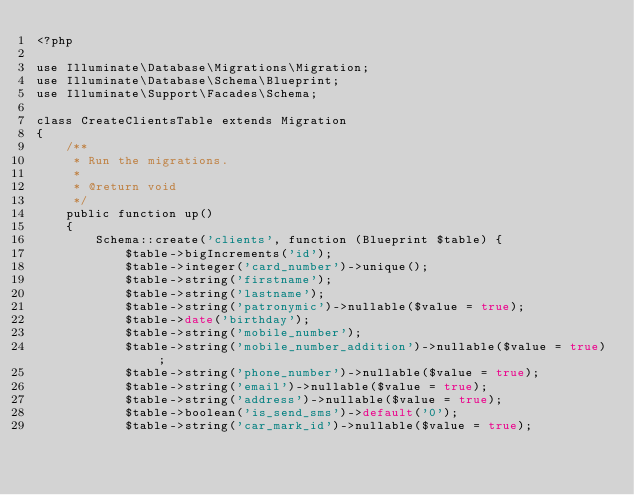<code> <loc_0><loc_0><loc_500><loc_500><_PHP_><?php

use Illuminate\Database\Migrations\Migration;
use Illuminate\Database\Schema\Blueprint;
use Illuminate\Support\Facades\Schema;

class CreateClientsTable extends Migration
{
    /**
     * Run the migrations.
     *
     * @return void
     */
    public function up()
    {
        Schema::create('clients', function (Blueprint $table) {
            $table->bigIncrements('id');
            $table->integer('card_number')->unique();
            $table->string('firstname');
            $table->string('lastname');
            $table->string('patronymic')->nullable($value = true);
            $table->date('birthday');
            $table->string('mobile_number');
            $table->string('mobile_number_addition')->nullable($value = true);
            $table->string('phone_number')->nullable($value = true);
            $table->string('email')->nullable($value = true);
            $table->string('address')->nullable($value = true);
            $table->boolean('is_send_sms')->default('0');
            $table->string('car_mark_id')->nullable($value = true);</code> 